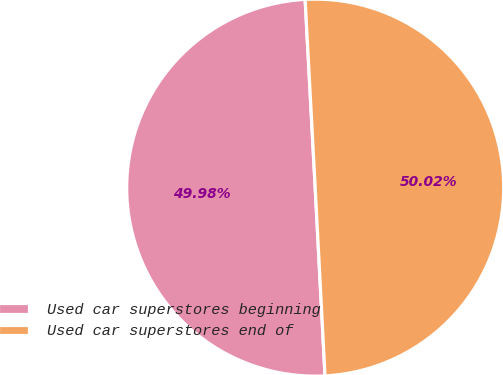Convert chart to OTSL. <chart><loc_0><loc_0><loc_500><loc_500><pie_chart><fcel>Used car superstores beginning<fcel>Used car superstores end of<nl><fcel>49.98%<fcel>50.02%<nl></chart> 